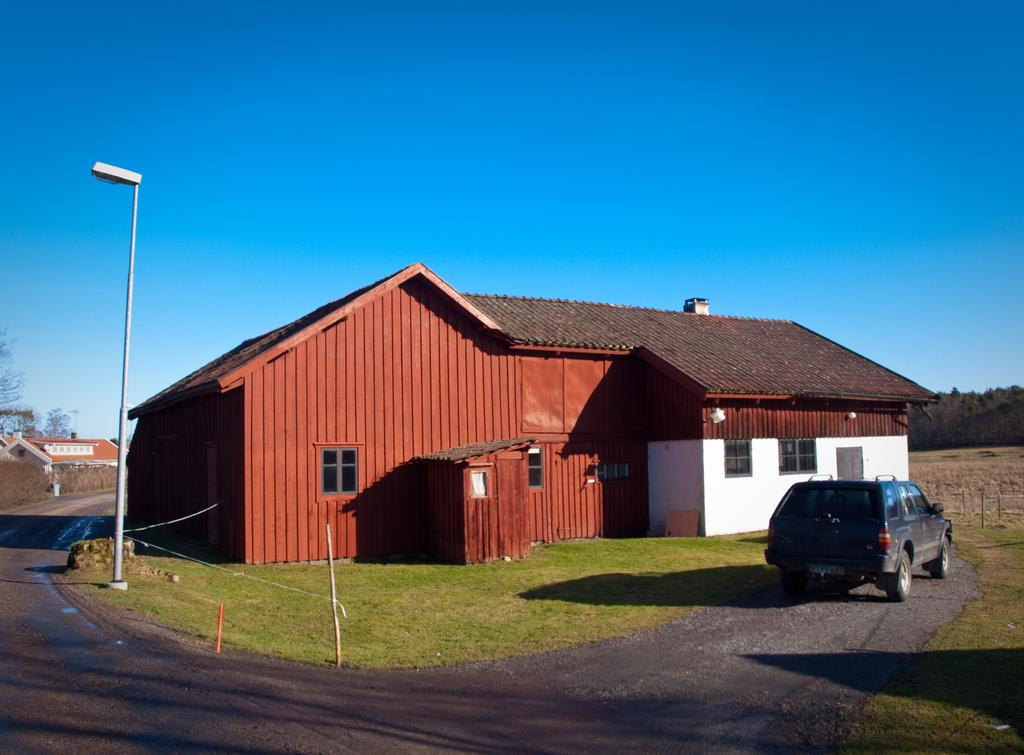What type of buildings can be seen in the image? There are houses in the image. What natural elements are present in the image? There are trees and grass on the ground in the image. What artificial light source is visible in the image? There is a pole light in the image. What type of vehicle is parked in the image? A car is parked in the image, and it is black in color. What is the color of the sky in the image? The sky is blue in the image. Are there any dolls playing in the rain in the image? There are no dolls or rain present in the image. What type of structure is located behind the houses in the image? The provided facts do not mention any structure behind the houses; only houses, trees, a pole light, a car, grass, and the sky are mentioned. 